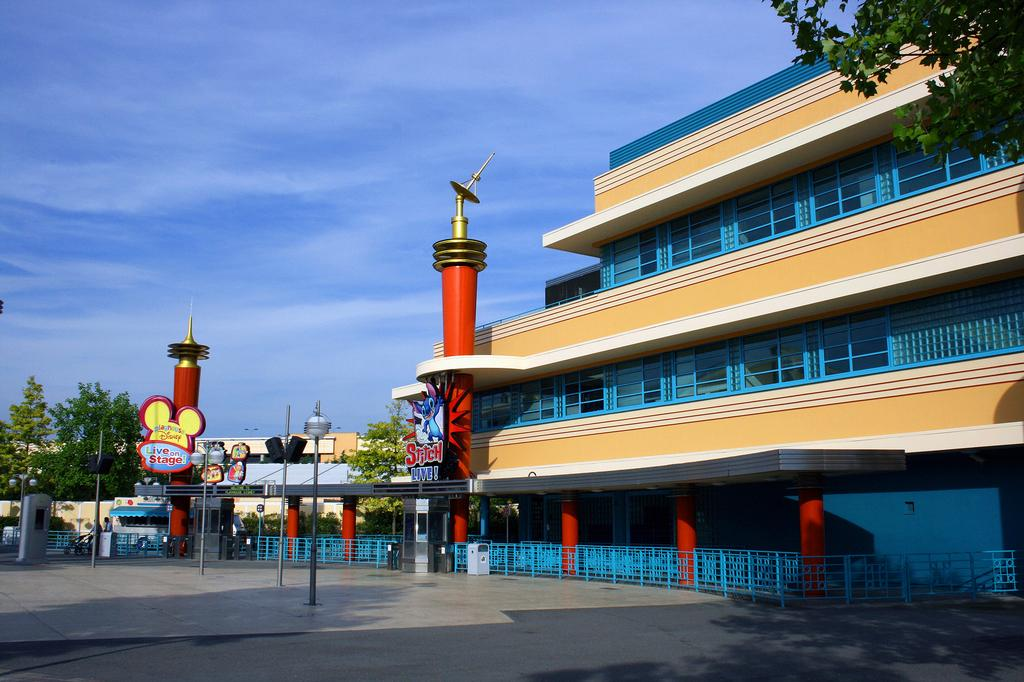What can be seen in the center of the image? In the center of the image, there are poles, fences, banners, vehicles, shops, and people. What is visible in the background of the image? In the background of the image, the sky, clouds, buildings, and trees can be seen. What type of rice is being cooked in the basin in the image? There is no rice or basin present in the image. What are the people learning in the image? The image does not depict any learning activities, so it cannot be determined what the people might be learning. 